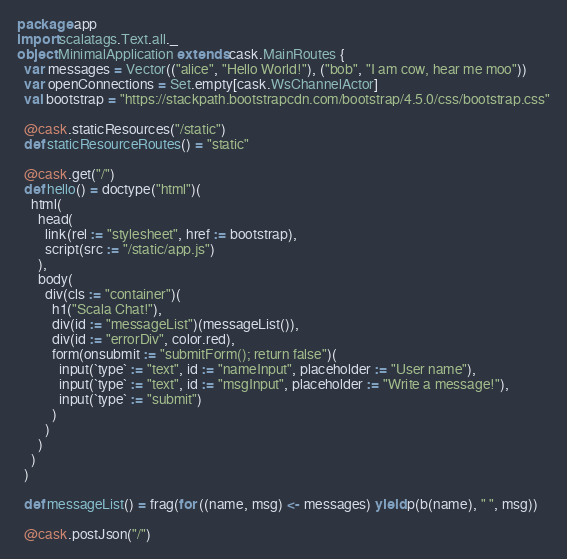<code> <loc_0><loc_0><loc_500><loc_500><_Scala_>package app
import scalatags.Text.all._
object MinimalApplication extends cask.MainRoutes {
  var messages = Vector(("alice", "Hello World!"), ("bob", "I am cow, hear me moo"))
  var openConnections = Set.empty[cask.WsChannelActor]
  val bootstrap = "https://stackpath.bootstrapcdn.com/bootstrap/4.5.0/css/bootstrap.css"

  @cask.staticResources("/static")
  def staticResourceRoutes() = "static"

  @cask.get("/")
  def hello() = doctype("html")(
    html(
      head(
        link(rel := "stylesheet", href := bootstrap),
        script(src := "/static/app.js")
      ),
      body(
        div(cls := "container")(
          h1("Scala Chat!"),
          div(id := "messageList")(messageList()),
          div(id := "errorDiv", color.red),
          form(onsubmit := "submitForm(); return false")(
            input(`type` := "text", id := "nameInput", placeholder := "User name"),
            input(`type` := "text", id := "msgInput", placeholder := "Write a message!"),
            input(`type` := "submit")
          )
        )
      )
    )
  )

  def messageList() = frag(for ((name, msg) <- messages) yield p(b(name), " ", msg))

  @cask.postJson("/")</code> 